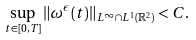Convert formula to latex. <formula><loc_0><loc_0><loc_500><loc_500>\sup _ { t \in [ 0 , T ] } \| \omega ^ { \epsilon } ( t ) \| _ { L ^ { \infty } \cap L ^ { 1 } ( \mathbb { R } ^ { 2 } ) } < C .</formula> 